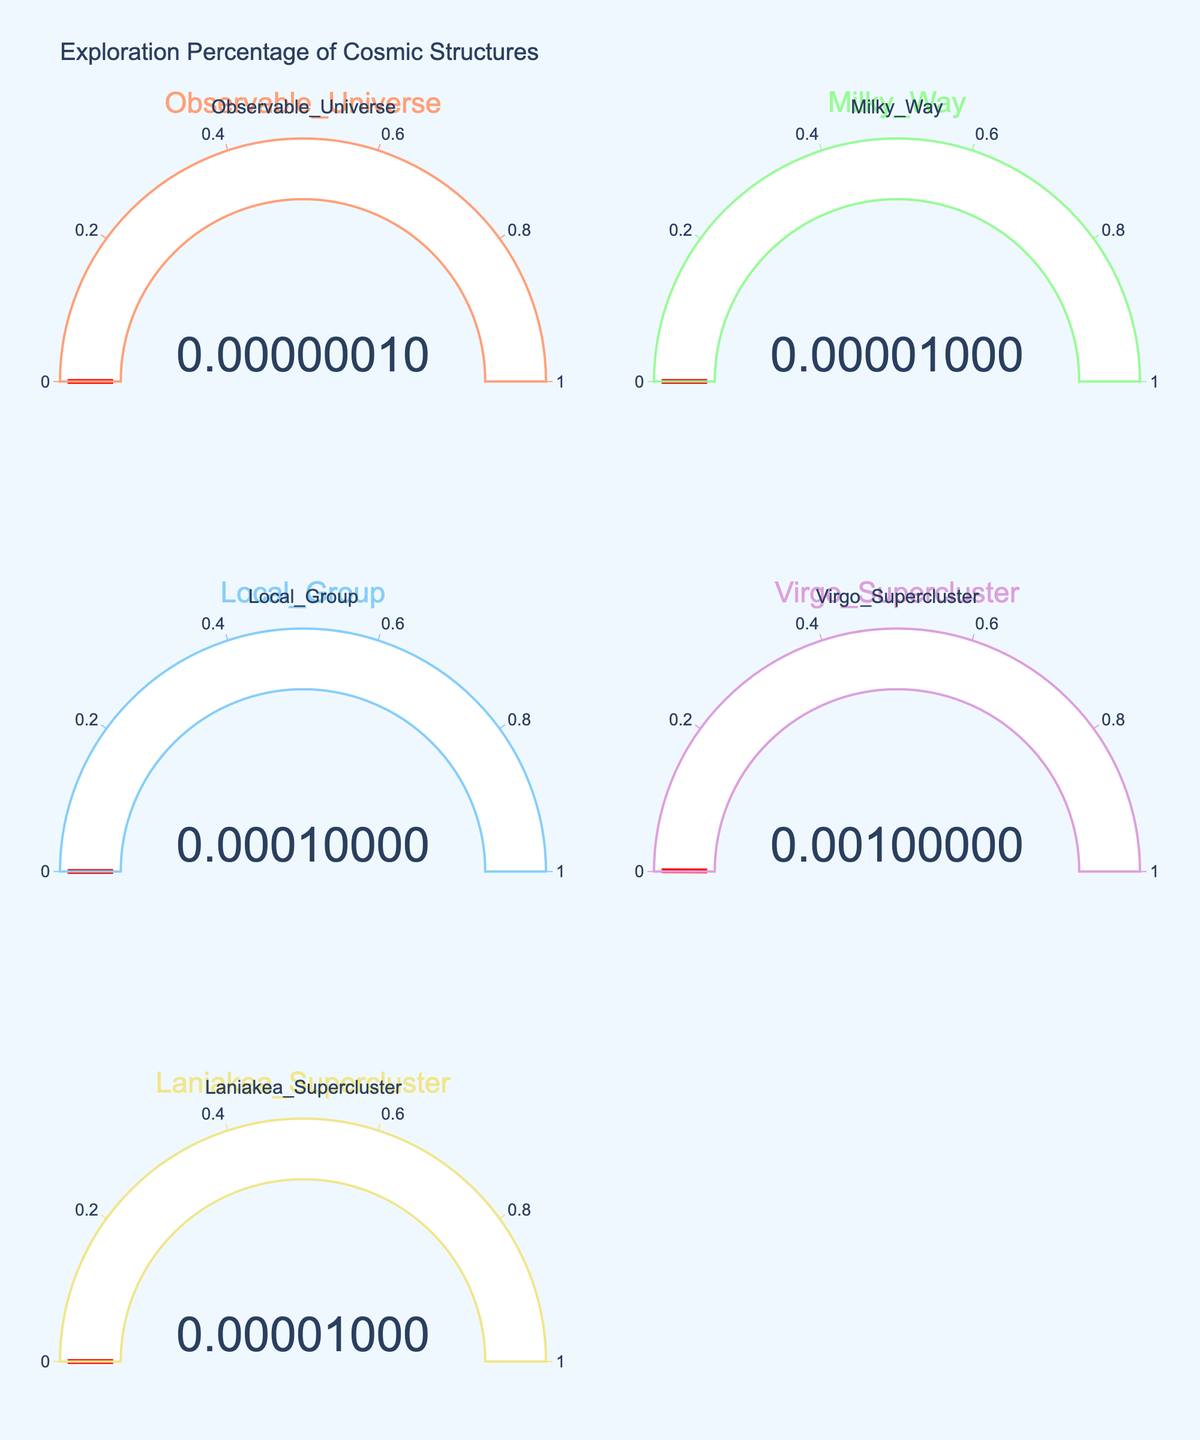What's the title of the figure? The title is displayed at the top of the figure and gives an overview of the visualized data.
Answer: Exploration Percentage of Cosmic Structures How many categories of celestial objects are shown in the figure? There is one gauge for each celestial object, and there are five gauges in the figure, each corresponding to a different celestial object.
Answer: Five Which celestial object has the lowest exploration percentage? By looking at the values displayed on the gauges, the object with the lowest number represents the least explored.
Answer: Observable Universe What is the exploration percentage of the Virgo Supercluster? There is a gauge labeled 'Virgo Supercluster', and its exploration percentage is displayed as the value on that gauge.
Answer: 0.001 What is the combined exploration percentage for the Milky Way and the Laniakea Supercluster? Adding the exploration percentages displayed on the gauges for these two objects achieves the combined percentage. The Milky Way has 0.00001 and the Laniakea Supercluster also has 0.00001, thus 0.00001 + 0.00001 = 0.00002
Answer: 0.00002 Which is more explored: the Local Group or the Observable Universe? Compare the two values directly from their gauges. The Local Group has 0.0001 while the Observable Universe has 0.0000001, making the Local Group more explored.
Answer: Local Group What color represents the Virgo Supercluster in the figure? Observing the color of the gauge used for the Virgo Supercluster will show its color, which is a visual cue in the figure.
Answer: Purple Which gauge has the highest value and what is that value? Scan the gauges to find the one with the highest number displayed. The one with 0.001 represents the highest value, which is for the Virgo Supercluster.
Answer: Virgo Supercluster, 0.001 What's the average of the exploration percentages of all celestial objects? Add all exploration percentages and divide by the number of celestial objects: (0.0000001 + 0.00001 + 0.0001 + 0.001 + 0.00001) / 5 = 0.000224 / 5 = 0.0000448
Answer: 0.0000448 